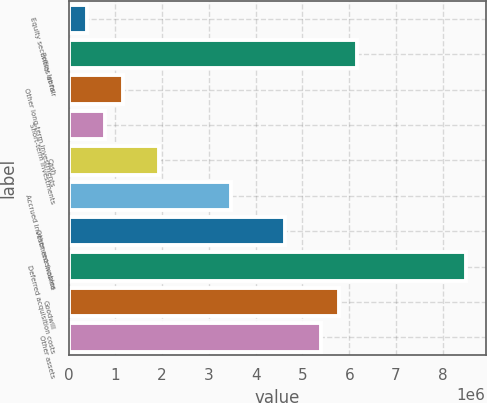Convert chart to OTSL. <chart><loc_0><loc_0><loc_500><loc_500><bar_chart><fcel>Equity securities at fair<fcel>Policy loans<fcel>Other long-term investments<fcel>Short-term investments<fcel>Cash<fcel>Accrued investment income<fcel>Other receivables<fcel>Deferred acquisition costs<fcel>Goodwill<fcel>Other assets<nl><fcel>385963<fcel>6.17541e+06<fcel>1.15789e+06<fcel>771926<fcel>1.92982e+06<fcel>3.47367e+06<fcel>4.63156e+06<fcel>8.49119e+06<fcel>5.78945e+06<fcel>5.40348e+06<nl></chart> 